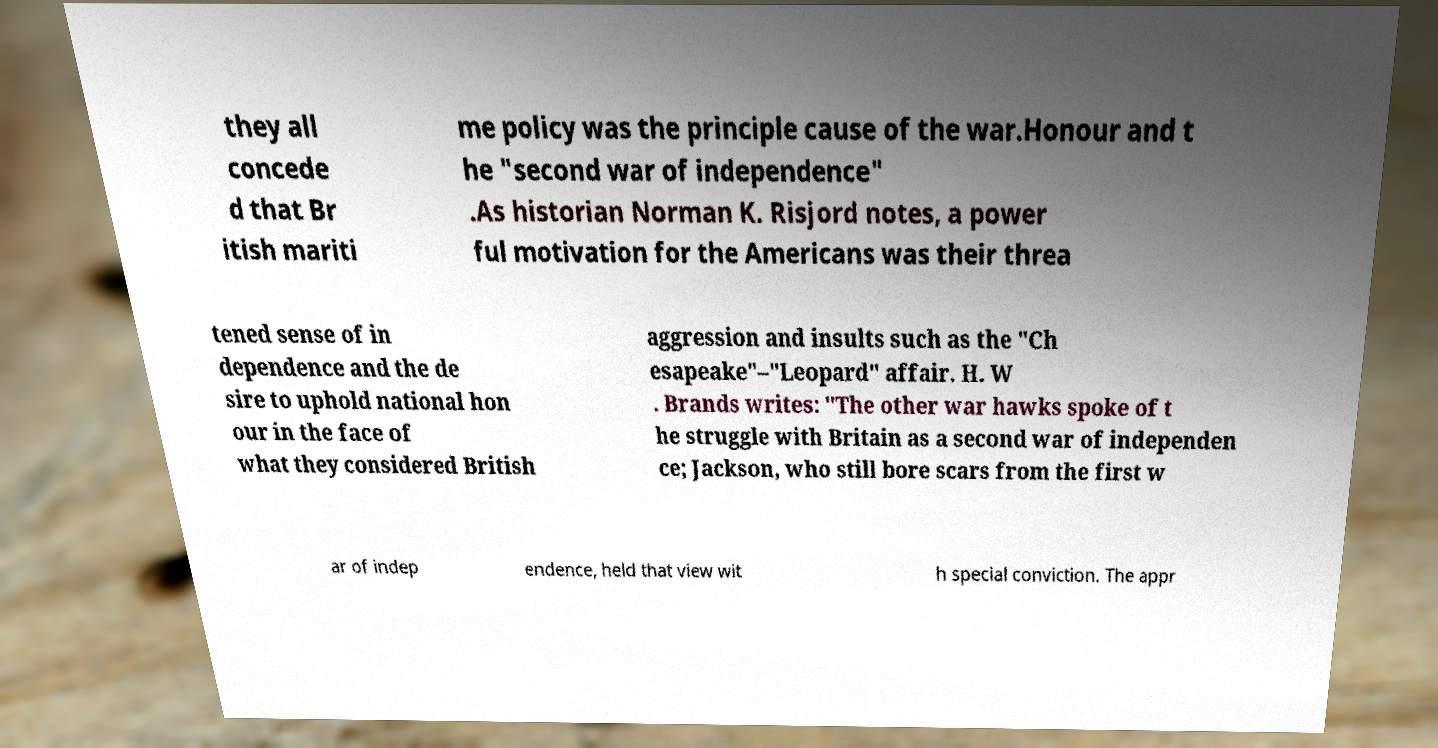What messages or text are displayed in this image? I need them in a readable, typed format. they all concede d that Br itish mariti me policy was the principle cause of the war.Honour and t he "second war of independence" .As historian Norman K. Risjord notes, a power ful motivation for the Americans was their threa tened sense of in dependence and the de sire to uphold national hon our in the face of what they considered British aggression and insults such as the "Ch esapeake"–"Leopard" affair. H. W . Brands writes: "The other war hawks spoke of t he struggle with Britain as a second war of independen ce; Jackson, who still bore scars from the first w ar of indep endence, held that view wit h special conviction. The appr 